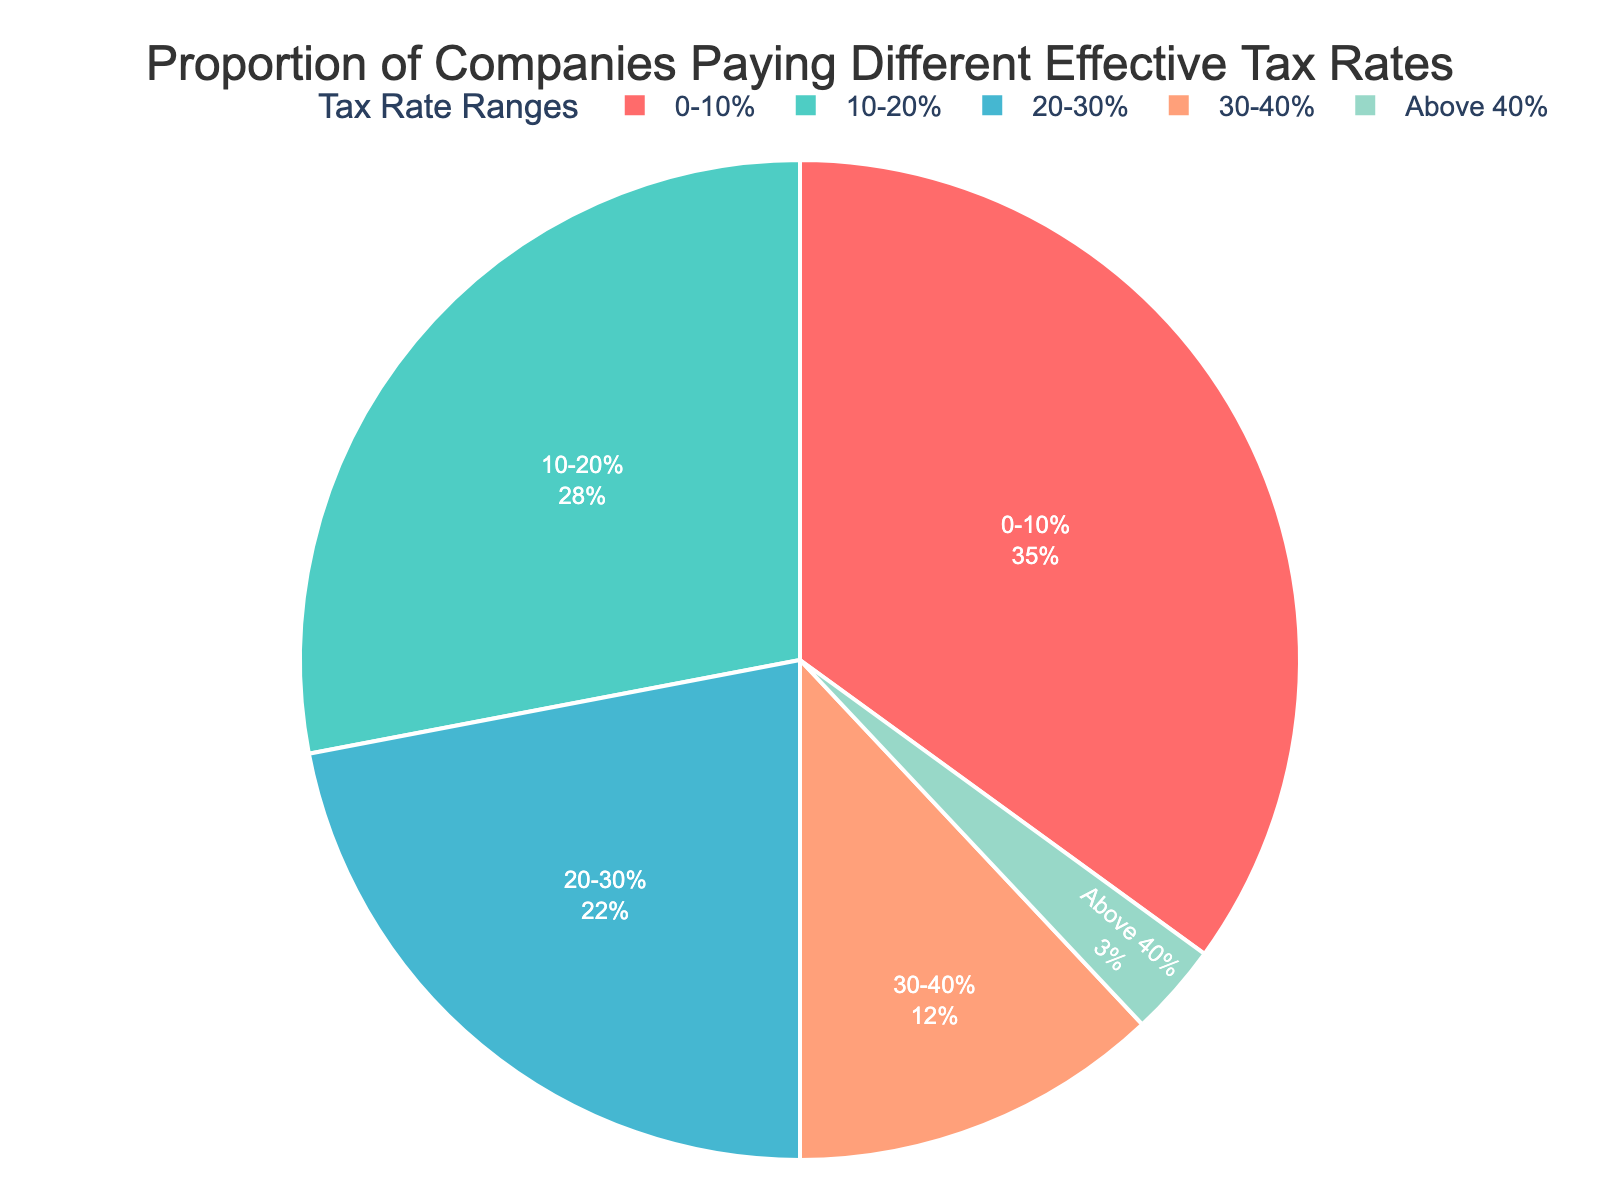What percentage of companies pay an effective tax rate of 20-30%? The sector labeled "20-30%" represents 22% of the companies.
Answer: 22% Which tax rate range has the largest proportion of companies? The largest portion on the pie chart is represented by the "0-10%" segment, which is 35% of companies.
Answer: 0-10% Is the combined percentage of companies paying an effective tax rate between 0-20% greater or less than 50%? Adding the percentages for "0-10%" and "10-20%": 35% + 28% = 63%. Thus, 63% is greater than 50%.
Answer: Greater What color represents the companies paying above 40% effective tax rate and what is their proportion? The segment representing "Above 40%" is colored in greenish hues and accounts for 3% of the companies.
Answer: Greenish hue, 3% Which color segment on the pie chart accounts for the smallest proportion of companies? The smallest segment is "Above 40%" at 3% which is colored in greenish hues.
Answer: Greenish hue How does the proportion of companies paying 10-20% compare with those paying 30-40%? The percentage for the "10-20%" range is 28%, while for the "30-40%" range, it is 12%. Thus, companies paying 10-20% effective tax rate are more than twice as many as those paying 30-40%.
Answer: More than twice as many What is the total percentage of companies paying less than 30% in effective tax rate? Adding the sections of "0-10%", "10-20%", and "20-30%": 35% + 28% + 22% = 85%. Hence, 85% of companies pay less than 30% in effective tax rate.
Answer: 85% Which tax rate range is represented by the red segment, and what is its percentage? The red segment represents the "0-10%" tax rate range, which constitutes 35% of companies.
Answer: 0-10%, 35% Is the percentage of companies paying 20-30% tax rate less than or greater than those paying 10-20% tax rate? The companies paying 20-30% make up 22%, whereas those paying 10-20% make up 28%. Therefore, the 20-30% segment is less than the 10-20% segment.
Answer: Less 